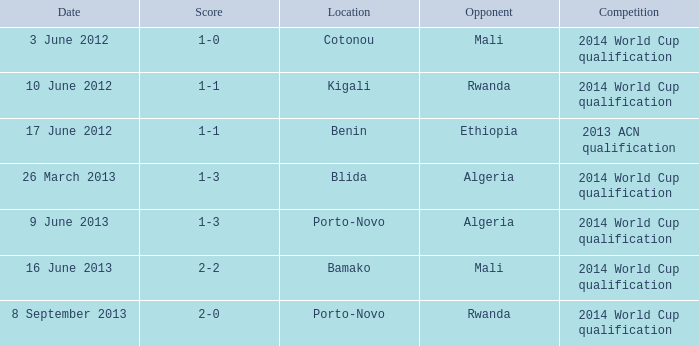What is the score from the game where Algeria is the opponent at Porto-Novo? 1-3. 